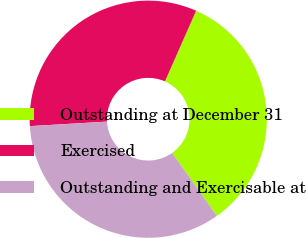Convert chart to OTSL. <chart><loc_0><loc_0><loc_500><loc_500><pie_chart><fcel>Outstanding at December 31<fcel>Exercised<fcel>Outstanding and Exercisable at<nl><fcel>33.56%<fcel>32.55%<fcel>33.89%<nl></chart> 